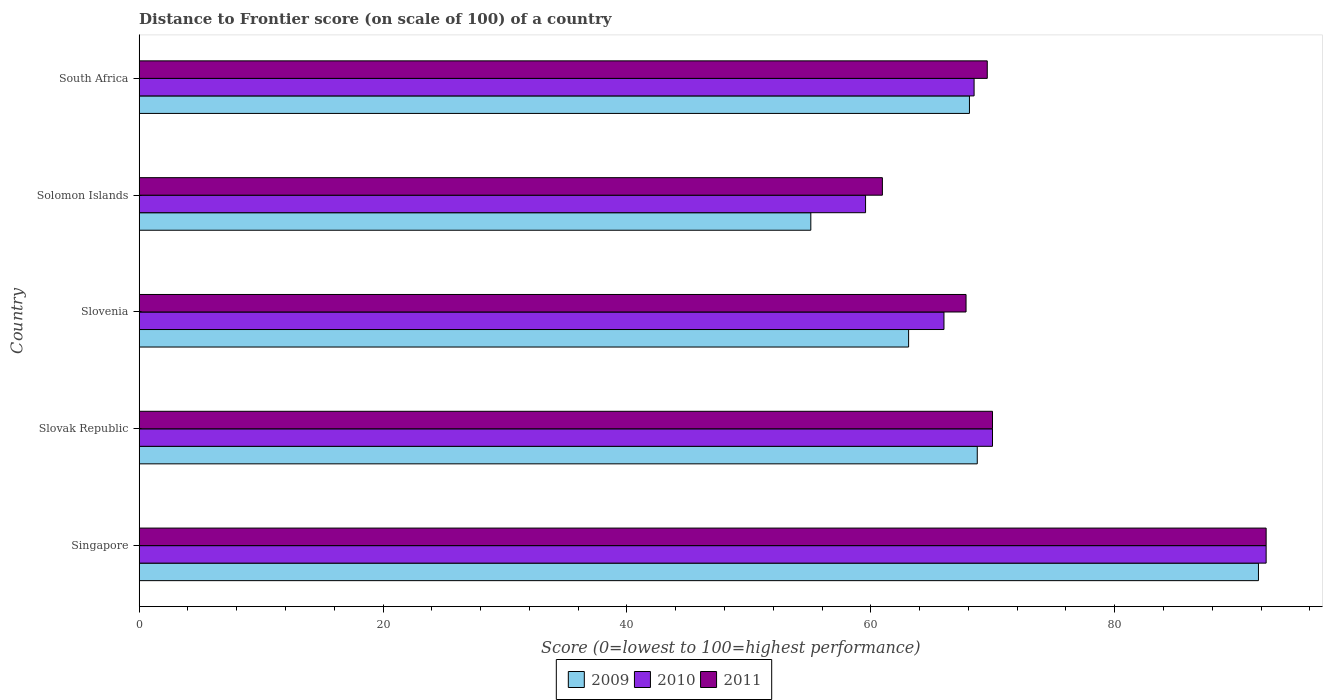How many different coloured bars are there?
Your answer should be compact. 3. What is the label of the 4th group of bars from the top?
Offer a very short reply. Slovak Republic. In how many cases, is the number of bars for a given country not equal to the number of legend labels?
Your answer should be very brief. 0. What is the distance to frontier score of in 2010 in South Africa?
Offer a very short reply. 68.47. Across all countries, what is the maximum distance to frontier score of in 2010?
Your answer should be very brief. 92.42. Across all countries, what is the minimum distance to frontier score of in 2010?
Provide a succinct answer. 59.57. In which country was the distance to frontier score of in 2010 maximum?
Offer a terse response. Singapore. In which country was the distance to frontier score of in 2010 minimum?
Provide a short and direct response. Solomon Islands. What is the total distance to frontier score of in 2010 in the graph?
Provide a succinct answer. 356.44. What is the difference between the distance to frontier score of in 2010 in Singapore and that in Slovak Republic?
Provide a short and direct response. 22.44. What is the difference between the distance to frontier score of in 2011 in Slovak Republic and the distance to frontier score of in 2010 in Solomon Islands?
Provide a succinct answer. 10.41. What is the average distance to frontier score of in 2009 per country?
Provide a succinct answer. 69.36. What is the difference between the distance to frontier score of in 2009 and distance to frontier score of in 2011 in South Africa?
Give a very brief answer. -1.46. In how many countries, is the distance to frontier score of in 2009 greater than 56 ?
Your answer should be compact. 4. What is the ratio of the distance to frontier score of in 2011 in Slovenia to that in South Africa?
Provide a succinct answer. 0.97. What is the difference between the highest and the second highest distance to frontier score of in 2010?
Make the answer very short. 22.44. What is the difference between the highest and the lowest distance to frontier score of in 2009?
Provide a short and direct response. 36.71. In how many countries, is the distance to frontier score of in 2009 greater than the average distance to frontier score of in 2009 taken over all countries?
Provide a short and direct response. 1. Is the sum of the distance to frontier score of in 2009 in Slovenia and South Africa greater than the maximum distance to frontier score of in 2011 across all countries?
Offer a very short reply. Yes. What does the 2nd bar from the top in South Africa represents?
Provide a succinct answer. 2010. What does the 3rd bar from the bottom in Slovak Republic represents?
Your answer should be compact. 2011. How many countries are there in the graph?
Ensure brevity in your answer.  5. What is the difference between two consecutive major ticks on the X-axis?
Ensure brevity in your answer.  20. Does the graph contain grids?
Give a very brief answer. No. Where does the legend appear in the graph?
Your answer should be very brief. Bottom center. How many legend labels are there?
Offer a terse response. 3. How are the legend labels stacked?
Provide a short and direct response. Horizontal. What is the title of the graph?
Give a very brief answer. Distance to Frontier score (on scale of 100) of a country. What is the label or title of the X-axis?
Offer a terse response. Score (0=lowest to 100=highest performance). What is the Score (0=lowest to 100=highest performance) of 2009 in Singapore?
Your answer should be compact. 91.79. What is the Score (0=lowest to 100=highest performance) of 2010 in Singapore?
Keep it short and to the point. 92.42. What is the Score (0=lowest to 100=highest performance) of 2011 in Singapore?
Your response must be concise. 92.42. What is the Score (0=lowest to 100=highest performance) of 2009 in Slovak Republic?
Give a very brief answer. 68.73. What is the Score (0=lowest to 100=highest performance) of 2010 in Slovak Republic?
Keep it short and to the point. 69.98. What is the Score (0=lowest to 100=highest performance) of 2011 in Slovak Republic?
Keep it short and to the point. 69.98. What is the Score (0=lowest to 100=highest performance) in 2009 in Slovenia?
Ensure brevity in your answer.  63.1. What is the Score (0=lowest to 100=highest performance) in 2011 in Slovenia?
Offer a terse response. 67.81. What is the Score (0=lowest to 100=highest performance) of 2009 in Solomon Islands?
Your answer should be compact. 55.08. What is the Score (0=lowest to 100=highest performance) of 2010 in Solomon Islands?
Your answer should be very brief. 59.57. What is the Score (0=lowest to 100=highest performance) in 2011 in Solomon Islands?
Provide a succinct answer. 60.95. What is the Score (0=lowest to 100=highest performance) of 2009 in South Africa?
Ensure brevity in your answer.  68.09. What is the Score (0=lowest to 100=highest performance) of 2010 in South Africa?
Your answer should be very brief. 68.47. What is the Score (0=lowest to 100=highest performance) of 2011 in South Africa?
Provide a succinct answer. 69.55. Across all countries, what is the maximum Score (0=lowest to 100=highest performance) in 2009?
Your response must be concise. 91.79. Across all countries, what is the maximum Score (0=lowest to 100=highest performance) in 2010?
Provide a succinct answer. 92.42. Across all countries, what is the maximum Score (0=lowest to 100=highest performance) of 2011?
Ensure brevity in your answer.  92.42. Across all countries, what is the minimum Score (0=lowest to 100=highest performance) of 2009?
Keep it short and to the point. 55.08. Across all countries, what is the minimum Score (0=lowest to 100=highest performance) of 2010?
Your response must be concise. 59.57. Across all countries, what is the minimum Score (0=lowest to 100=highest performance) in 2011?
Give a very brief answer. 60.95. What is the total Score (0=lowest to 100=highest performance) of 2009 in the graph?
Provide a short and direct response. 346.79. What is the total Score (0=lowest to 100=highest performance) in 2010 in the graph?
Provide a succinct answer. 356.44. What is the total Score (0=lowest to 100=highest performance) of 2011 in the graph?
Provide a short and direct response. 360.71. What is the difference between the Score (0=lowest to 100=highest performance) in 2009 in Singapore and that in Slovak Republic?
Keep it short and to the point. 23.06. What is the difference between the Score (0=lowest to 100=highest performance) in 2010 in Singapore and that in Slovak Republic?
Provide a short and direct response. 22.44. What is the difference between the Score (0=lowest to 100=highest performance) of 2011 in Singapore and that in Slovak Republic?
Provide a succinct answer. 22.44. What is the difference between the Score (0=lowest to 100=highest performance) in 2009 in Singapore and that in Slovenia?
Provide a short and direct response. 28.69. What is the difference between the Score (0=lowest to 100=highest performance) of 2010 in Singapore and that in Slovenia?
Offer a very short reply. 26.42. What is the difference between the Score (0=lowest to 100=highest performance) in 2011 in Singapore and that in Slovenia?
Provide a short and direct response. 24.61. What is the difference between the Score (0=lowest to 100=highest performance) of 2009 in Singapore and that in Solomon Islands?
Ensure brevity in your answer.  36.71. What is the difference between the Score (0=lowest to 100=highest performance) of 2010 in Singapore and that in Solomon Islands?
Provide a succinct answer. 32.85. What is the difference between the Score (0=lowest to 100=highest performance) in 2011 in Singapore and that in Solomon Islands?
Offer a terse response. 31.47. What is the difference between the Score (0=lowest to 100=highest performance) of 2009 in Singapore and that in South Africa?
Keep it short and to the point. 23.7. What is the difference between the Score (0=lowest to 100=highest performance) of 2010 in Singapore and that in South Africa?
Ensure brevity in your answer.  23.95. What is the difference between the Score (0=lowest to 100=highest performance) of 2011 in Singapore and that in South Africa?
Provide a succinct answer. 22.87. What is the difference between the Score (0=lowest to 100=highest performance) of 2009 in Slovak Republic and that in Slovenia?
Give a very brief answer. 5.63. What is the difference between the Score (0=lowest to 100=highest performance) of 2010 in Slovak Republic and that in Slovenia?
Give a very brief answer. 3.98. What is the difference between the Score (0=lowest to 100=highest performance) in 2011 in Slovak Republic and that in Slovenia?
Ensure brevity in your answer.  2.17. What is the difference between the Score (0=lowest to 100=highest performance) of 2009 in Slovak Republic and that in Solomon Islands?
Give a very brief answer. 13.65. What is the difference between the Score (0=lowest to 100=highest performance) of 2010 in Slovak Republic and that in Solomon Islands?
Offer a terse response. 10.41. What is the difference between the Score (0=lowest to 100=highest performance) of 2011 in Slovak Republic and that in Solomon Islands?
Keep it short and to the point. 9.03. What is the difference between the Score (0=lowest to 100=highest performance) of 2009 in Slovak Republic and that in South Africa?
Offer a very short reply. 0.64. What is the difference between the Score (0=lowest to 100=highest performance) of 2010 in Slovak Republic and that in South Africa?
Your answer should be compact. 1.51. What is the difference between the Score (0=lowest to 100=highest performance) in 2011 in Slovak Republic and that in South Africa?
Provide a short and direct response. 0.43. What is the difference between the Score (0=lowest to 100=highest performance) of 2009 in Slovenia and that in Solomon Islands?
Offer a terse response. 8.02. What is the difference between the Score (0=lowest to 100=highest performance) of 2010 in Slovenia and that in Solomon Islands?
Your answer should be compact. 6.43. What is the difference between the Score (0=lowest to 100=highest performance) in 2011 in Slovenia and that in Solomon Islands?
Give a very brief answer. 6.86. What is the difference between the Score (0=lowest to 100=highest performance) of 2009 in Slovenia and that in South Africa?
Keep it short and to the point. -4.99. What is the difference between the Score (0=lowest to 100=highest performance) of 2010 in Slovenia and that in South Africa?
Offer a terse response. -2.47. What is the difference between the Score (0=lowest to 100=highest performance) of 2011 in Slovenia and that in South Africa?
Your answer should be compact. -1.74. What is the difference between the Score (0=lowest to 100=highest performance) of 2009 in Solomon Islands and that in South Africa?
Your answer should be very brief. -13.01. What is the difference between the Score (0=lowest to 100=highest performance) of 2010 in Solomon Islands and that in South Africa?
Keep it short and to the point. -8.9. What is the difference between the Score (0=lowest to 100=highest performance) in 2009 in Singapore and the Score (0=lowest to 100=highest performance) in 2010 in Slovak Republic?
Your response must be concise. 21.81. What is the difference between the Score (0=lowest to 100=highest performance) of 2009 in Singapore and the Score (0=lowest to 100=highest performance) of 2011 in Slovak Republic?
Offer a terse response. 21.81. What is the difference between the Score (0=lowest to 100=highest performance) of 2010 in Singapore and the Score (0=lowest to 100=highest performance) of 2011 in Slovak Republic?
Your response must be concise. 22.44. What is the difference between the Score (0=lowest to 100=highest performance) of 2009 in Singapore and the Score (0=lowest to 100=highest performance) of 2010 in Slovenia?
Offer a very short reply. 25.79. What is the difference between the Score (0=lowest to 100=highest performance) in 2009 in Singapore and the Score (0=lowest to 100=highest performance) in 2011 in Slovenia?
Your answer should be very brief. 23.98. What is the difference between the Score (0=lowest to 100=highest performance) of 2010 in Singapore and the Score (0=lowest to 100=highest performance) of 2011 in Slovenia?
Make the answer very short. 24.61. What is the difference between the Score (0=lowest to 100=highest performance) of 2009 in Singapore and the Score (0=lowest to 100=highest performance) of 2010 in Solomon Islands?
Your response must be concise. 32.22. What is the difference between the Score (0=lowest to 100=highest performance) in 2009 in Singapore and the Score (0=lowest to 100=highest performance) in 2011 in Solomon Islands?
Offer a very short reply. 30.84. What is the difference between the Score (0=lowest to 100=highest performance) in 2010 in Singapore and the Score (0=lowest to 100=highest performance) in 2011 in Solomon Islands?
Provide a succinct answer. 31.47. What is the difference between the Score (0=lowest to 100=highest performance) of 2009 in Singapore and the Score (0=lowest to 100=highest performance) of 2010 in South Africa?
Make the answer very short. 23.32. What is the difference between the Score (0=lowest to 100=highest performance) of 2009 in Singapore and the Score (0=lowest to 100=highest performance) of 2011 in South Africa?
Give a very brief answer. 22.24. What is the difference between the Score (0=lowest to 100=highest performance) of 2010 in Singapore and the Score (0=lowest to 100=highest performance) of 2011 in South Africa?
Offer a terse response. 22.87. What is the difference between the Score (0=lowest to 100=highest performance) in 2009 in Slovak Republic and the Score (0=lowest to 100=highest performance) in 2010 in Slovenia?
Your response must be concise. 2.73. What is the difference between the Score (0=lowest to 100=highest performance) in 2010 in Slovak Republic and the Score (0=lowest to 100=highest performance) in 2011 in Slovenia?
Provide a succinct answer. 2.17. What is the difference between the Score (0=lowest to 100=highest performance) in 2009 in Slovak Republic and the Score (0=lowest to 100=highest performance) in 2010 in Solomon Islands?
Make the answer very short. 9.16. What is the difference between the Score (0=lowest to 100=highest performance) in 2009 in Slovak Republic and the Score (0=lowest to 100=highest performance) in 2011 in Solomon Islands?
Make the answer very short. 7.78. What is the difference between the Score (0=lowest to 100=highest performance) of 2010 in Slovak Republic and the Score (0=lowest to 100=highest performance) of 2011 in Solomon Islands?
Keep it short and to the point. 9.03. What is the difference between the Score (0=lowest to 100=highest performance) in 2009 in Slovak Republic and the Score (0=lowest to 100=highest performance) in 2010 in South Africa?
Make the answer very short. 0.26. What is the difference between the Score (0=lowest to 100=highest performance) of 2009 in Slovak Republic and the Score (0=lowest to 100=highest performance) of 2011 in South Africa?
Offer a terse response. -0.82. What is the difference between the Score (0=lowest to 100=highest performance) of 2010 in Slovak Republic and the Score (0=lowest to 100=highest performance) of 2011 in South Africa?
Provide a short and direct response. 0.43. What is the difference between the Score (0=lowest to 100=highest performance) of 2009 in Slovenia and the Score (0=lowest to 100=highest performance) of 2010 in Solomon Islands?
Offer a terse response. 3.53. What is the difference between the Score (0=lowest to 100=highest performance) in 2009 in Slovenia and the Score (0=lowest to 100=highest performance) in 2011 in Solomon Islands?
Make the answer very short. 2.15. What is the difference between the Score (0=lowest to 100=highest performance) in 2010 in Slovenia and the Score (0=lowest to 100=highest performance) in 2011 in Solomon Islands?
Keep it short and to the point. 5.05. What is the difference between the Score (0=lowest to 100=highest performance) of 2009 in Slovenia and the Score (0=lowest to 100=highest performance) of 2010 in South Africa?
Give a very brief answer. -5.37. What is the difference between the Score (0=lowest to 100=highest performance) of 2009 in Slovenia and the Score (0=lowest to 100=highest performance) of 2011 in South Africa?
Make the answer very short. -6.45. What is the difference between the Score (0=lowest to 100=highest performance) in 2010 in Slovenia and the Score (0=lowest to 100=highest performance) in 2011 in South Africa?
Provide a short and direct response. -3.55. What is the difference between the Score (0=lowest to 100=highest performance) in 2009 in Solomon Islands and the Score (0=lowest to 100=highest performance) in 2010 in South Africa?
Make the answer very short. -13.39. What is the difference between the Score (0=lowest to 100=highest performance) in 2009 in Solomon Islands and the Score (0=lowest to 100=highest performance) in 2011 in South Africa?
Provide a short and direct response. -14.47. What is the difference between the Score (0=lowest to 100=highest performance) in 2010 in Solomon Islands and the Score (0=lowest to 100=highest performance) in 2011 in South Africa?
Provide a succinct answer. -9.98. What is the average Score (0=lowest to 100=highest performance) in 2009 per country?
Make the answer very short. 69.36. What is the average Score (0=lowest to 100=highest performance) in 2010 per country?
Provide a short and direct response. 71.29. What is the average Score (0=lowest to 100=highest performance) in 2011 per country?
Your answer should be compact. 72.14. What is the difference between the Score (0=lowest to 100=highest performance) in 2009 and Score (0=lowest to 100=highest performance) in 2010 in Singapore?
Offer a terse response. -0.63. What is the difference between the Score (0=lowest to 100=highest performance) in 2009 and Score (0=lowest to 100=highest performance) in 2011 in Singapore?
Ensure brevity in your answer.  -0.63. What is the difference between the Score (0=lowest to 100=highest performance) in 2010 and Score (0=lowest to 100=highest performance) in 2011 in Singapore?
Offer a very short reply. 0. What is the difference between the Score (0=lowest to 100=highest performance) of 2009 and Score (0=lowest to 100=highest performance) of 2010 in Slovak Republic?
Keep it short and to the point. -1.25. What is the difference between the Score (0=lowest to 100=highest performance) of 2009 and Score (0=lowest to 100=highest performance) of 2011 in Slovak Republic?
Your response must be concise. -1.25. What is the difference between the Score (0=lowest to 100=highest performance) in 2010 and Score (0=lowest to 100=highest performance) in 2011 in Slovak Republic?
Give a very brief answer. 0. What is the difference between the Score (0=lowest to 100=highest performance) in 2009 and Score (0=lowest to 100=highest performance) in 2011 in Slovenia?
Your answer should be very brief. -4.71. What is the difference between the Score (0=lowest to 100=highest performance) of 2010 and Score (0=lowest to 100=highest performance) of 2011 in Slovenia?
Give a very brief answer. -1.81. What is the difference between the Score (0=lowest to 100=highest performance) in 2009 and Score (0=lowest to 100=highest performance) in 2010 in Solomon Islands?
Keep it short and to the point. -4.49. What is the difference between the Score (0=lowest to 100=highest performance) in 2009 and Score (0=lowest to 100=highest performance) in 2011 in Solomon Islands?
Offer a terse response. -5.87. What is the difference between the Score (0=lowest to 100=highest performance) of 2010 and Score (0=lowest to 100=highest performance) of 2011 in Solomon Islands?
Keep it short and to the point. -1.38. What is the difference between the Score (0=lowest to 100=highest performance) in 2009 and Score (0=lowest to 100=highest performance) in 2010 in South Africa?
Give a very brief answer. -0.38. What is the difference between the Score (0=lowest to 100=highest performance) in 2009 and Score (0=lowest to 100=highest performance) in 2011 in South Africa?
Provide a short and direct response. -1.46. What is the difference between the Score (0=lowest to 100=highest performance) of 2010 and Score (0=lowest to 100=highest performance) of 2011 in South Africa?
Offer a terse response. -1.08. What is the ratio of the Score (0=lowest to 100=highest performance) in 2009 in Singapore to that in Slovak Republic?
Your answer should be compact. 1.34. What is the ratio of the Score (0=lowest to 100=highest performance) in 2010 in Singapore to that in Slovak Republic?
Make the answer very short. 1.32. What is the ratio of the Score (0=lowest to 100=highest performance) in 2011 in Singapore to that in Slovak Republic?
Keep it short and to the point. 1.32. What is the ratio of the Score (0=lowest to 100=highest performance) in 2009 in Singapore to that in Slovenia?
Your response must be concise. 1.45. What is the ratio of the Score (0=lowest to 100=highest performance) of 2010 in Singapore to that in Slovenia?
Provide a short and direct response. 1.4. What is the ratio of the Score (0=lowest to 100=highest performance) of 2011 in Singapore to that in Slovenia?
Ensure brevity in your answer.  1.36. What is the ratio of the Score (0=lowest to 100=highest performance) of 2009 in Singapore to that in Solomon Islands?
Give a very brief answer. 1.67. What is the ratio of the Score (0=lowest to 100=highest performance) of 2010 in Singapore to that in Solomon Islands?
Provide a short and direct response. 1.55. What is the ratio of the Score (0=lowest to 100=highest performance) of 2011 in Singapore to that in Solomon Islands?
Provide a short and direct response. 1.52. What is the ratio of the Score (0=lowest to 100=highest performance) of 2009 in Singapore to that in South Africa?
Your response must be concise. 1.35. What is the ratio of the Score (0=lowest to 100=highest performance) of 2010 in Singapore to that in South Africa?
Make the answer very short. 1.35. What is the ratio of the Score (0=lowest to 100=highest performance) in 2011 in Singapore to that in South Africa?
Make the answer very short. 1.33. What is the ratio of the Score (0=lowest to 100=highest performance) in 2009 in Slovak Republic to that in Slovenia?
Offer a terse response. 1.09. What is the ratio of the Score (0=lowest to 100=highest performance) of 2010 in Slovak Republic to that in Slovenia?
Make the answer very short. 1.06. What is the ratio of the Score (0=lowest to 100=highest performance) in 2011 in Slovak Republic to that in Slovenia?
Provide a short and direct response. 1.03. What is the ratio of the Score (0=lowest to 100=highest performance) in 2009 in Slovak Republic to that in Solomon Islands?
Your answer should be very brief. 1.25. What is the ratio of the Score (0=lowest to 100=highest performance) in 2010 in Slovak Republic to that in Solomon Islands?
Keep it short and to the point. 1.17. What is the ratio of the Score (0=lowest to 100=highest performance) of 2011 in Slovak Republic to that in Solomon Islands?
Provide a short and direct response. 1.15. What is the ratio of the Score (0=lowest to 100=highest performance) in 2009 in Slovak Republic to that in South Africa?
Your response must be concise. 1.01. What is the ratio of the Score (0=lowest to 100=highest performance) in 2010 in Slovak Republic to that in South Africa?
Your response must be concise. 1.02. What is the ratio of the Score (0=lowest to 100=highest performance) in 2011 in Slovak Republic to that in South Africa?
Provide a short and direct response. 1.01. What is the ratio of the Score (0=lowest to 100=highest performance) in 2009 in Slovenia to that in Solomon Islands?
Give a very brief answer. 1.15. What is the ratio of the Score (0=lowest to 100=highest performance) in 2010 in Slovenia to that in Solomon Islands?
Ensure brevity in your answer.  1.11. What is the ratio of the Score (0=lowest to 100=highest performance) in 2011 in Slovenia to that in Solomon Islands?
Your response must be concise. 1.11. What is the ratio of the Score (0=lowest to 100=highest performance) in 2009 in Slovenia to that in South Africa?
Provide a succinct answer. 0.93. What is the ratio of the Score (0=lowest to 100=highest performance) of 2010 in Slovenia to that in South Africa?
Offer a very short reply. 0.96. What is the ratio of the Score (0=lowest to 100=highest performance) of 2009 in Solomon Islands to that in South Africa?
Your response must be concise. 0.81. What is the ratio of the Score (0=lowest to 100=highest performance) of 2010 in Solomon Islands to that in South Africa?
Give a very brief answer. 0.87. What is the ratio of the Score (0=lowest to 100=highest performance) in 2011 in Solomon Islands to that in South Africa?
Your answer should be compact. 0.88. What is the difference between the highest and the second highest Score (0=lowest to 100=highest performance) in 2009?
Offer a very short reply. 23.06. What is the difference between the highest and the second highest Score (0=lowest to 100=highest performance) of 2010?
Give a very brief answer. 22.44. What is the difference between the highest and the second highest Score (0=lowest to 100=highest performance) in 2011?
Ensure brevity in your answer.  22.44. What is the difference between the highest and the lowest Score (0=lowest to 100=highest performance) in 2009?
Keep it short and to the point. 36.71. What is the difference between the highest and the lowest Score (0=lowest to 100=highest performance) of 2010?
Give a very brief answer. 32.85. What is the difference between the highest and the lowest Score (0=lowest to 100=highest performance) in 2011?
Your answer should be very brief. 31.47. 